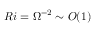Convert formula to latex. <formula><loc_0><loc_0><loc_500><loc_500>R i = \Omega ^ { - 2 } \sim O ( 1 )</formula> 